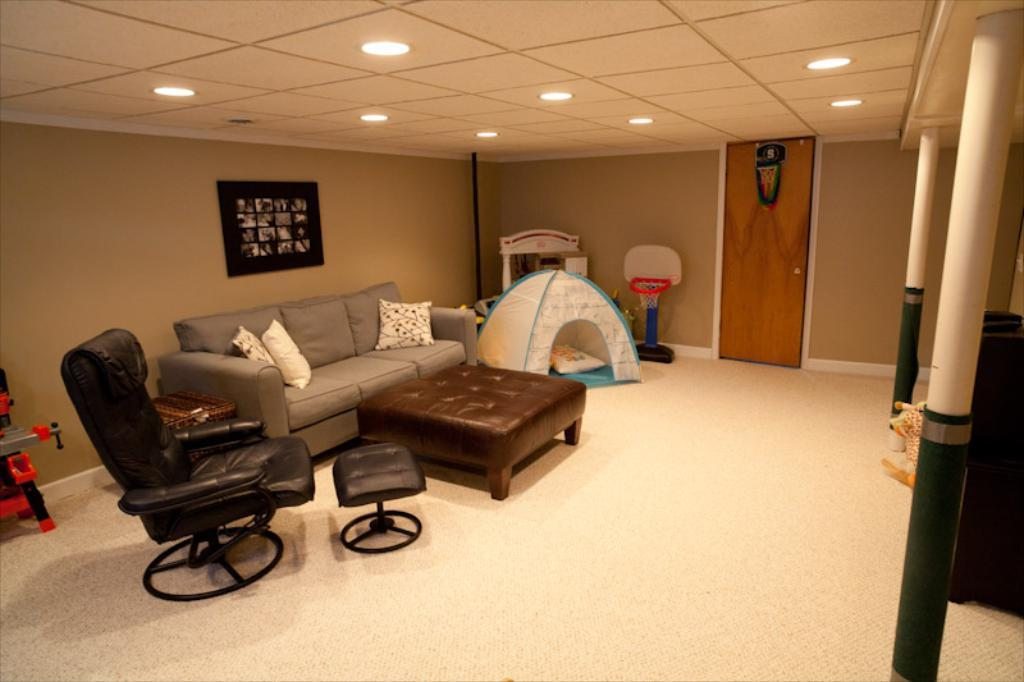What type of furniture is present in the image? There is a sofa and a chair in the image. What architectural feature can be seen in the image? There is a door in the image. What part of the room is visible in the image? The ceiling is visible in the image. What type of decoration is present on the wall in the image? There is a wall photo on the wall in the image. How does the heart in the image beat in sync with the music? There is no heart present in the image; it is a room with a sofa, chair, door, ceiling, and wall photo. 